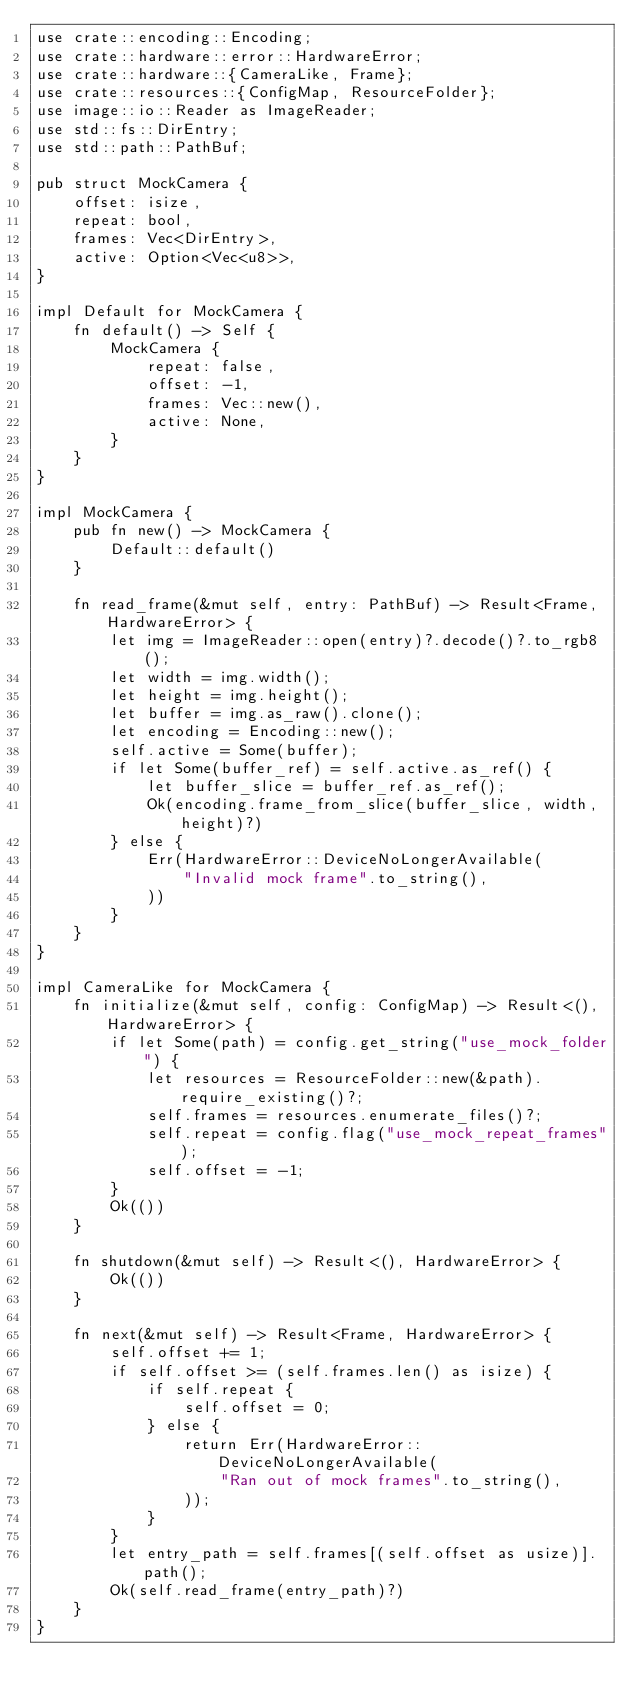<code> <loc_0><loc_0><loc_500><loc_500><_Rust_>use crate::encoding::Encoding;
use crate::hardware::error::HardwareError;
use crate::hardware::{CameraLike, Frame};
use crate::resources::{ConfigMap, ResourceFolder};
use image::io::Reader as ImageReader;
use std::fs::DirEntry;
use std::path::PathBuf;

pub struct MockCamera {
    offset: isize,
    repeat: bool,
    frames: Vec<DirEntry>,
    active: Option<Vec<u8>>,
}

impl Default for MockCamera {
    fn default() -> Self {
        MockCamera {
            repeat: false,
            offset: -1,
            frames: Vec::new(),
            active: None,
        }
    }
}

impl MockCamera {
    pub fn new() -> MockCamera {
        Default::default()
    }

    fn read_frame(&mut self, entry: PathBuf) -> Result<Frame, HardwareError> {
        let img = ImageReader::open(entry)?.decode()?.to_rgb8();
        let width = img.width();
        let height = img.height();
        let buffer = img.as_raw().clone();
        let encoding = Encoding::new();
        self.active = Some(buffer);
        if let Some(buffer_ref) = self.active.as_ref() {
            let buffer_slice = buffer_ref.as_ref();
            Ok(encoding.frame_from_slice(buffer_slice, width, height)?)
        } else {
            Err(HardwareError::DeviceNoLongerAvailable(
                "Invalid mock frame".to_string(),
            ))
        }
    }
}

impl CameraLike for MockCamera {
    fn initialize(&mut self, config: ConfigMap) -> Result<(), HardwareError> {
        if let Some(path) = config.get_string("use_mock_folder") {
            let resources = ResourceFolder::new(&path).require_existing()?;
            self.frames = resources.enumerate_files()?;
            self.repeat = config.flag("use_mock_repeat_frames");
            self.offset = -1;
        }
        Ok(())
    }

    fn shutdown(&mut self) -> Result<(), HardwareError> {
        Ok(())
    }

    fn next(&mut self) -> Result<Frame, HardwareError> {
        self.offset += 1;
        if self.offset >= (self.frames.len() as isize) {
            if self.repeat {
                self.offset = 0;
            } else {
                return Err(HardwareError::DeviceNoLongerAvailable(
                    "Ran out of mock frames".to_string(),
                ));
            }
        }
        let entry_path = self.frames[(self.offset as usize)].path();
        Ok(self.read_frame(entry_path)?)
    }
}
</code> 